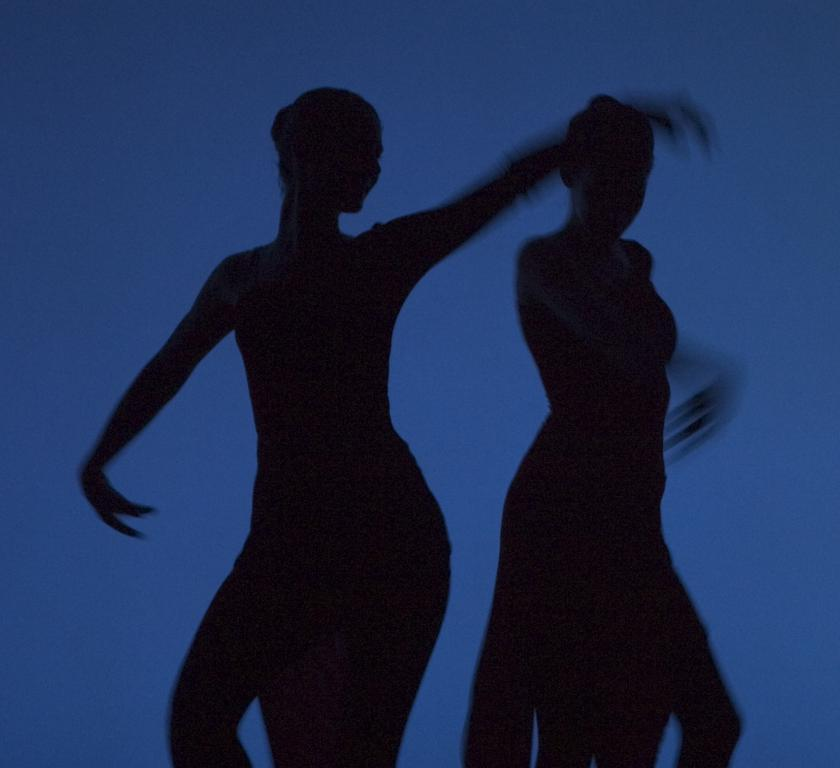What are the people in the image doing? There are persons dancing in the image. Can you tell me how far away the earthquake is from the dancers in the image? There is no earthquake present in the image; it only shows people dancing. 